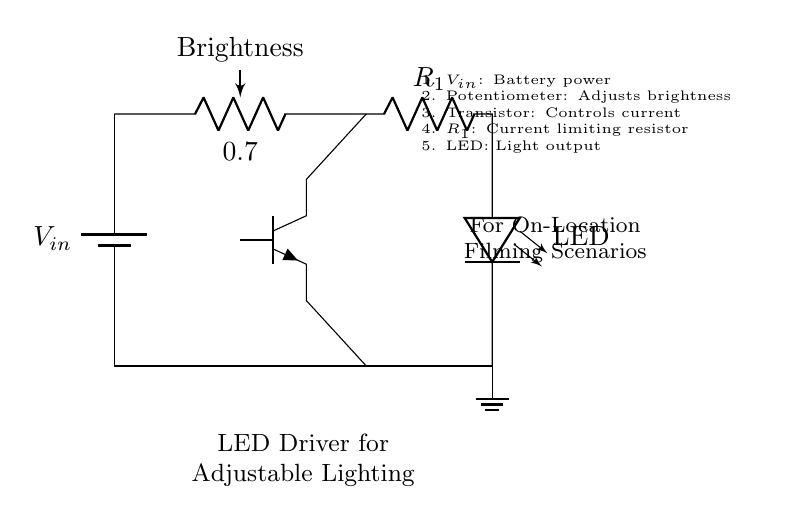What type of circuit is this? This is an LED driver circuit designed for adjustable lighting. This is indicated by the presence of a potentiometer to adjust brightness and an LED as the light output.
Answer: LED driver circuit What component is used to adjust brightness? The brightness is adjusted by a potentiometer, which is specifically indicated in the circuit diagram and labeled with "Brightness".
Answer: Potentiometer What is the function of the transistor in this circuit? The transistor acts as a current control device, ensuring that the LED receives the appropriate amount of current based on the brightness setting. Its connections to both the potentiometer and the LED confirm this role.
Answer: Current control What is the purpose of resistor R1? Resistor R1 is a current limiting resistor that ensures the LED does not receive excessive current, which could damage it. This function is critical in protecting the LED as indicated in the circuit's annotations.
Answer: Current limiting How many main components are depicted in the circuit? The circuit diagram contains five main components: a battery, potentiometer, resistor, transistor, and LED. Counting these components confirms that there are five important elements in the circuit.
Answer: Five What type of light output is used in this circuit? The circuit uses an LED for light output, as explicitly stated in the annotations of the circuit diagram. This can be confirmed by the component labeled as LED.
Answer: LED 